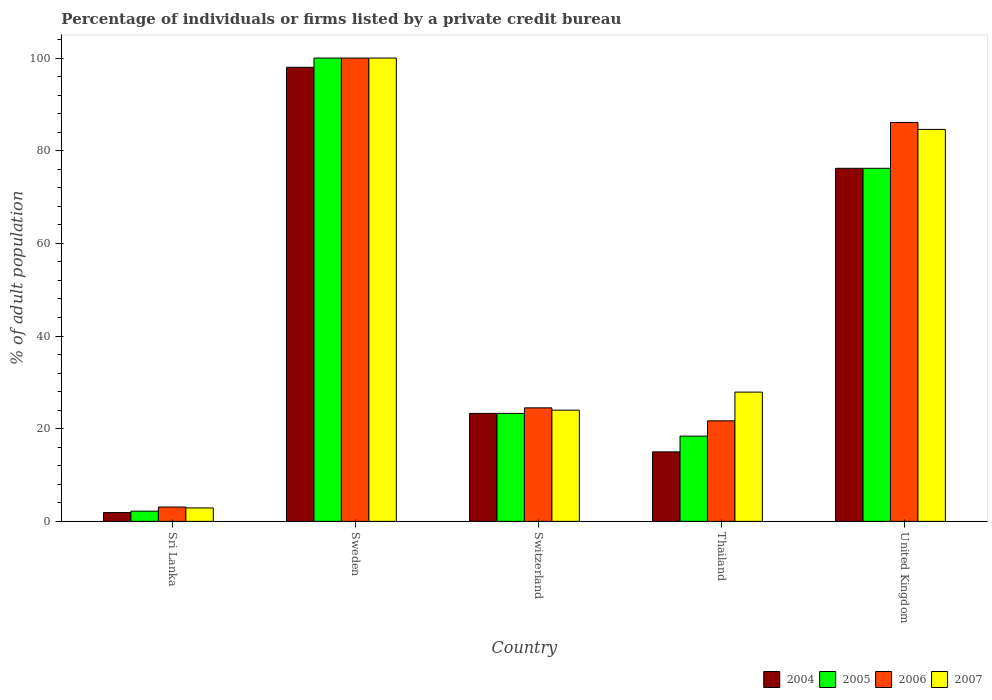How many bars are there on the 2nd tick from the right?
Make the answer very short. 4. What is the label of the 3rd group of bars from the left?
Your answer should be very brief. Switzerland. In how many cases, is the number of bars for a given country not equal to the number of legend labels?
Your answer should be compact. 0. What is the percentage of population listed by a private credit bureau in 2004 in Sri Lanka?
Your response must be concise. 1.9. In which country was the percentage of population listed by a private credit bureau in 2005 maximum?
Your response must be concise. Sweden. In which country was the percentage of population listed by a private credit bureau in 2007 minimum?
Provide a succinct answer. Sri Lanka. What is the total percentage of population listed by a private credit bureau in 2004 in the graph?
Provide a short and direct response. 214.4. What is the difference between the percentage of population listed by a private credit bureau in 2006 in Sri Lanka and that in United Kingdom?
Make the answer very short. -83. What is the difference between the percentage of population listed by a private credit bureau in 2004 in Sri Lanka and the percentage of population listed by a private credit bureau in 2006 in Sweden?
Ensure brevity in your answer.  -98.1. What is the average percentage of population listed by a private credit bureau in 2004 per country?
Your answer should be very brief. 42.88. What is the ratio of the percentage of population listed by a private credit bureau in 2006 in Sri Lanka to that in United Kingdom?
Make the answer very short. 0.04. Is the percentage of population listed by a private credit bureau in 2006 in Sri Lanka less than that in United Kingdom?
Give a very brief answer. Yes. Is the difference between the percentage of population listed by a private credit bureau in 2005 in Thailand and United Kingdom greater than the difference between the percentage of population listed by a private credit bureau in 2007 in Thailand and United Kingdom?
Offer a terse response. No. What is the difference between the highest and the second highest percentage of population listed by a private credit bureau in 2004?
Your answer should be compact. 21.8. What is the difference between the highest and the lowest percentage of population listed by a private credit bureau in 2005?
Give a very brief answer. 97.8. In how many countries, is the percentage of population listed by a private credit bureau in 2006 greater than the average percentage of population listed by a private credit bureau in 2006 taken over all countries?
Your answer should be compact. 2. Is it the case that in every country, the sum of the percentage of population listed by a private credit bureau in 2005 and percentage of population listed by a private credit bureau in 2007 is greater than the sum of percentage of population listed by a private credit bureau in 2004 and percentage of population listed by a private credit bureau in 2006?
Provide a succinct answer. No. What does the 2nd bar from the left in Sweden represents?
Ensure brevity in your answer.  2005. What does the 1st bar from the right in Switzerland represents?
Provide a short and direct response. 2007. How many bars are there?
Offer a very short reply. 20. How many countries are there in the graph?
Offer a terse response. 5. What is the difference between two consecutive major ticks on the Y-axis?
Keep it short and to the point. 20. Does the graph contain any zero values?
Keep it short and to the point. No. Does the graph contain grids?
Your response must be concise. No. Where does the legend appear in the graph?
Offer a terse response. Bottom right. How many legend labels are there?
Your answer should be compact. 4. How are the legend labels stacked?
Provide a short and direct response. Horizontal. What is the title of the graph?
Your answer should be compact. Percentage of individuals or firms listed by a private credit bureau. Does "1975" appear as one of the legend labels in the graph?
Give a very brief answer. No. What is the label or title of the Y-axis?
Your response must be concise. % of adult population. What is the % of adult population of 2006 in Sri Lanka?
Make the answer very short. 3.1. What is the % of adult population in 2007 in Sri Lanka?
Ensure brevity in your answer.  2.9. What is the % of adult population in 2004 in Sweden?
Give a very brief answer. 98. What is the % of adult population of 2006 in Sweden?
Ensure brevity in your answer.  100. What is the % of adult population of 2007 in Sweden?
Give a very brief answer. 100. What is the % of adult population in 2004 in Switzerland?
Keep it short and to the point. 23.3. What is the % of adult population of 2005 in Switzerland?
Offer a very short reply. 23.3. What is the % of adult population of 2007 in Switzerland?
Keep it short and to the point. 24. What is the % of adult population of 2004 in Thailand?
Make the answer very short. 15. What is the % of adult population in 2005 in Thailand?
Make the answer very short. 18.4. What is the % of adult population in 2006 in Thailand?
Provide a short and direct response. 21.7. What is the % of adult population in 2007 in Thailand?
Your answer should be compact. 27.9. What is the % of adult population in 2004 in United Kingdom?
Offer a terse response. 76.2. What is the % of adult population in 2005 in United Kingdom?
Offer a terse response. 76.2. What is the % of adult population of 2006 in United Kingdom?
Provide a succinct answer. 86.1. What is the % of adult population in 2007 in United Kingdom?
Provide a succinct answer. 84.6. Across all countries, what is the maximum % of adult population of 2006?
Offer a very short reply. 100. Across all countries, what is the minimum % of adult population in 2004?
Give a very brief answer. 1.9. What is the total % of adult population of 2004 in the graph?
Give a very brief answer. 214.4. What is the total % of adult population of 2005 in the graph?
Make the answer very short. 220.1. What is the total % of adult population in 2006 in the graph?
Make the answer very short. 235.4. What is the total % of adult population in 2007 in the graph?
Give a very brief answer. 239.4. What is the difference between the % of adult population of 2004 in Sri Lanka and that in Sweden?
Make the answer very short. -96.1. What is the difference between the % of adult population of 2005 in Sri Lanka and that in Sweden?
Offer a terse response. -97.8. What is the difference between the % of adult population in 2006 in Sri Lanka and that in Sweden?
Your answer should be very brief. -96.9. What is the difference between the % of adult population in 2007 in Sri Lanka and that in Sweden?
Give a very brief answer. -97.1. What is the difference between the % of adult population of 2004 in Sri Lanka and that in Switzerland?
Your answer should be very brief. -21.4. What is the difference between the % of adult population of 2005 in Sri Lanka and that in Switzerland?
Offer a terse response. -21.1. What is the difference between the % of adult population in 2006 in Sri Lanka and that in Switzerland?
Keep it short and to the point. -21.4. What is the difference between the % of adult population of 2007 in Sri Lanka and that in Switzerland?
Provide a short and direct response. -21.1. What is the difference between the % of adult population in 2005 in Sri Lanka and that in Thailand?
Your answer should be very brief. -16.2. What is the difference between the % of adult population in 2006 in Sri Lanka and that in Thailand?
Offer a very short reply. -18.6. What is the difference between the % of adult population in 2004 in Sri Lanka and that in United Kingdom?
Make the answer very short. -74.3. What is the difference between the % of adult population of 2005 in Sri Lanka and that in United Kingdom?
Make the answer very short. -74. What is the difference between the % of adult population of 2006 in Sri Lanka and that in United Kingdom?
Make the answer very short. -83. What is the difference between the % of adult population in 2007 in Sri Lanka and that in United Kingdom?
Offer a terse response. -81.7. What is the difference between the % of adult population in 2004 in Sweden and that in Switzerland?
Your response must be concise. 74.7. What is the difference between the % of adult population in 2005 in Sweden and that in Switzerland?
Your response must be concise. 76.7. What is the difference between the % of adult population of 2006 in Sweden and that in Switzerland?
Offer a terse response. 75.5. What is the difference between the % of adult population in 2007 in Sweden and that in Switzerland?
Keep it short and to the point. 76. What is the difference between the % of adult population in 2004 in Sweden and that in Thailand?
Make the answer very short. 83. What is the difference between the % of adult population in 2005 in Sweden and that in Thailand?
Your answer should be compact. 81.6. What is the difference between the % of adult population of 2006 in Sweden and that in Thailand?
Offer a terse response. 78.3. What is the difference between the % of adult population of 2007 in Sweden and that in Thailand?
Provide a short and direct response. 72.1. What is the difference between the % of adult population of 2004 in Sweden and that in United Kingdom?
Make the answer very short. 21.8. What is the difference between the % of adult population of 2005 in Sweden and that in United Kingdom?
Provide a succinct answer. 23.8. What is the difference between the % of adult population of 2006 in Sweden and that in United Kingdom?
Offer a terse response. 13.9. What is the difference between the % of adult population of 2007 in Sweden and that in United Kingdom?
Ensure brevity in your answer.  15.4. What is the difference between the % of adult population of 2004 in Switzerland and that in Thailand?
Offer a very short reply. 8.3. What is the difference between the % of adult population of 2004 in Switzerland and that in United Kingdom?
Your answer should be compact. -52.9. What is the difference between the % of adult population of 2005 in Switzerland and that in United Kingdom?
Ensure brevity in your answer.  -52.9. What is the difference between the % of adult population of 2006 in Switzerland and that in United Kingdom?
Make the answer very short. -61.6. What is the difference between the % of adult population in 2007 in Switzerland and that in United Kingdom?
Make the answer very short. -60.6. What is the difference between the % of adult population of 2004 in Thailand and that in United Kingdom?
Your answer should be very brief. -61.2. What is the difference between the % of adult population in 2005 in Thailand and that in United Kingdom?
Give a very brief answer. -57.8. What is the difference between the % of adult population of 2006 in Thailand and that in United Kingdom?
Keep it short and to the point. -64.4. What is the difference between the % of adult population of 2007 in Thailand and that in United Kingdom?
Your answer should be very brief. -56.7. What is the difference between the % of adult population of 2004 in Sri Lanka and the % of adult population of 2005 in Sweden?
Provide a succinct answer. -98.1. What is the difference between the % of adult population in 2004 in Sri Lanka and the % of adult population in 2006 in Sweden?
Your response must be concise. -98.1. What is the difference between the % of adult population in 2004 in Sri Lanka and the % of adult population in 2007 in Sweden?
Provide a succinct answer. -98.1. What is the difference between the % of adult population in 2005 in Sri Lanka and the % of adult population in 2006 in Sweden?
Your answer should be compact. -97.8. What is the difference between the % of adult population of 2005 in Sri Lanka and the % of adult population of 2007 in Sweden?
Provide a short and direct response. -97.8. What is the difference between the % of adult population in 2006 in Sri Lanka and the % of adult population in 2007 in Sweden?
Offer a very short reply. -96.9. What is the difference between the % of adult population in 2004 in Sri Lanka and the % of adult population in 2005 in Switzerland?
Offer a very short reply. -21.4. What is the difference between the % of adult population in 2004 in Sri Lanka and the % of adult population in 2006 in Switzerland?
Keep it short and to the point. -22.6. What is the difference between the % of adult population in 2004 in Sri Lanka and the % of adult population in 2007 in Switzerland?
Your answer should be very brief. -22.1. What is the difference between the % of adult population of 2005 in Sri Lanka and the % of adult population of 2006 in Switzerland?
Make the answer very short. -22.3. What is the difference between the % of adult population of 2005 in Sri Lanka and the % of adult population of 2007 in Switzerland?
Make the answer very short. -21.8. What is the difference between the % of adult population in 2006 in Sri Lanka and the % of adult population in 2007 in Switzerland?
Offer a terse response. -20.9. What is the difference between the % of adult population of 2004 in Sri Lanka and the % of adult population of 2005 in Thailand?
Give a very brief answer. -16.5. What is the difference between the % of adult population in 2004 in Sri Lanka and the % of adult population in 2006 in Thailand?
Offer a terse response. -19.8. What is the difference between the % of adult population in 2005 in Sri Lanka and the % of adult population in 2006 in Thailand?
Your answer should be very brief. -19.5. What is the difference between the % of adult population in 2005 in Sri Lanka and the % of adult population in 2007 in Thailand?
Your answer should be very brief. -25.7. What is the difference between the % of adult population of 2006 in Sri Lanka and the % of adult population of 2007 in Thailand?
Offer a terse response. -24.8. What is the difference between the % of adult population in 2004 in Sri Lanka and the % of adult population in 2005 in United Kingdom?
Offer a very short reply. -74.3. What is the difference between the % of adult population in 2004 in Sri Lanka and the % of adult population in 2006 in United Kingdom?
Make the answer very short. -84.2. What is the difference between the % of adult population of 2004 in Sri Lanka and the % of adult population of 2007 in United Kingdom?
Offer a very short reply. -82.7. What is the difference between the % of adult population of 2005 in Sri Lanka and the % of adult population of 2006 in United Kingdom?
Make the answer very short. -83.9. What is the difference between the % of adult population of 2005 in Sri Lanka and the % of adult population of 2007 in United Kingdom?
Give a very brief answer. -82.4. What is the difference between the % of adult population of 2006 in Sri Lanka and the % of adult population of 2007 in United Kingdom?
Make the answer very short. -81.5. What is the difference between the % of adult population in 2004 in Sweden and the % of adult population in 2005 in Switzerland?
Offer a terse response. 74.7. What is the difference between the % of adult population in 2004 in Sweden and the % of adult population in 2006 in Switzerland?
Provide a succinct answer. 73.5. What is the difference between the % of adult population of 2004 in Sweden and the % of adult population of 2007 in Switzerland?
Keep it short and to the point. 74. What is the difference between the % of adult population of 2005 in Sweden and the % of adult population of 2006 in Switzerland?
Your response must be concise. 75.5. What is the difference between the % of adult population of 2004 in Sweden and the % of adult population of 2005 in Thailand?
Provide a succinct answer. 79.6. What is the difference between the % of adult population of 2004 in Sweden and the % of adult population of 2006 in Thailand?
Ensure brevity in your answer.  76.3. What is the difference between the % of adult population of 2004 in Sweden and the % of adult population of 2007 in Thailand?
Keep it short and to the point. 70.1. What is the difference between the % of adult population of 2005 in Sweden and the % of adult population of 2006 in Thailand?
Offer a very short reply. 78.3. What is the difference between the % of adult population in 2005 in Sweden and the % of adult population in 2007 in Thailand?
Make the answer very short. 72.1. What is the difference between the % of adult population in 2006 in Sweden and the % of adult population in 2007 in Thailand?
Ensure brevity in your answer.  72.1. What is the difference between the % of adult population in 2004 in Sweden and the % of adult population in 2005 in United Kingdom?
Keep it short and to the point. 21.8. What is the difference between the % of adult population in 2004 in Sweden and the % of adult population in 2007 in United Kingdom?
Ensure brevity in your answer.  13.4. What is the difference between the % of adult population in 2006 in Sweden and the % of adult population in 2007 in United Kingdom?
Provide a short and direct response. 15.4. What is the difference between the % of adult population in 2004 in Switzerland and the % of adult population in 2006 in Thailand?
Your answer should be very brief. 1.6. What is the difference between the % of adult population of 2004 in Switzerland and the % of adult population of 2007 in Thailand?
Offer a terse response. -4.6. What is the difference between the % of adult population in 2005 in Switzerland and the % of adult population in 2006 in Thailand?
Your response must be concise. 1.6. What is the difference between the % of adult population of 2006 in Switzerland and the % of adult population of 2007 in Thailand?
Make the answer very short. -3.4. What is the difference between the % of adult population of 2004 in Switzerland and the % of adult population of 2005 in United Kingdom?
Provide a succinct answer. -52.9. What is the difference between the % of adult population of 2004 in Switzerland and the % of adult population of 2006 in United Kingdom?
Make the answer very short. -62.8. What is the difference between the % of adult population of 2004 in Switzerland and the % of adult population of 2007 in United Kingdom?
Provide a short and direct response. -61.3. What is the difference between the % of adult population in 2005 in Switzerland and the % of adult population in 2006 in United Kingdom?
Ensure brevity in your answer.  -62.8. What is the difference between the % of adult population of 2005 in Switzerland and the % of adult population of 2007 in United Kingdom?
Offer a very short reply. -61.3. What is the difference between the % of adult population in 2006 in Switzerland and the % of adult population in 2007 in United Kingdom?
Make the answer very short. -60.1. What is the difference between the % of adult population of 2004 in Thailand and the % of adult population of 2005 in United Kingdom?
Ensure brevity in your answer.  -61.2. What is the difference between the % of adult population of 2004 in Thailand and the % of adult population of 2006 in United Kingdom?
Offer a very short reply. -71.1. What is the difference between the % of adult population of 2004 in Thailand and the % of adult population of 2007 in United Kingdom?
Your response must be concise. -69.6. What is the difference between the % of adult population of 2005 in Thailand and the % of adult population of 2006 in United Kingdom?
Keep it short and to the point. -67.7. What is the difference between the % of adult population of 2005 in Thailand and the % of adult population of 2007 in United Kingdom?
Offer a terse response. -66.2. What is the difference between the % of adult population in 2006 in Thailand and the % of adult population in 2007 in United Kingdom?
Ensure brevity in your answer.  -62.9. What is the average % of adult population of 2004 per country?
Provide a succinct answer. 42.88. What is the average % of adult population in 2005 per country?
Your answer should be very brief. 44.02. What is the average % of adult population in 2006 per country?
Offer a very short reply. 47.08. What is the average % of adult population in 2007 per country?
Make the answer very short. 47.88. What is the difference between the % of adult population of 2004 and % of adult population of 2005 in Sri Lanka?
Make the answer very short. -0.3. What is the difference between the % of adult population in 2004 and % of adult population in 2007 in Sri Lanka?
Keep it short and to the point. -1. What is the difference between the % of adult population in 2004 and % of adult population in 2007 in Sweden?
Your response must be concise. -2. What is the difference between the % of adult population of 2005 and % of adult population of 2007 in Sweden?
Offer a very short reply. 0. What is the difference between the % of adult population of 2006 and % of adult population of 2007 in Sweden?
Ensure brevity in your answer.  0. What is the difference between the % of adult population in 2004 and % of adult population in 2006 in Switzerland?
Offer a very short reply. -1.2. What is the difference between the % of adult population in 2004 and % of adult population in 2007 in Switzerland?
Provide a short and direct response. -0.7. What is the difference between the % of adult population in 2005 and % of adult population in 2007 in Switzerland?
Your response must be concise. -0.7. What is the difference between the % of adult population in 2006 and % of adult population in 2007 in Switzerland?
Offer a very short reply. 0.5. What is the difference between the % of adult population of 2005 and % of adult population of 2006 in Thailand?
Ensure brevity in your answer.  -3.3. What is the difference between the % of adult population in 2005 and % of adult population in 2007 in Thailand?
Provide a succinct answer. -9.5. What is the difference between the % of adult population of 2006 and % of adult population of 2007 in Thailand?
Ensure brevity in your answer.  -6.2. What is the difference between the % of adult population in 2005 and % of adult population in 2006 in United Kingdom?
Give a very brief answer. -9.9. What is the difference between the % of adult population in 2005 and % of adult population in 2007 in United Kingdom?
Keep it short and to the point. -8.4. What is the ratio of the % of adult population of 2004 in Sri Lanka to that in Sweden?
Your answer should be compact. 0.02. What is the ratio of the % of adult population in 2005 in Sri Lanka to that in Sweden?
Make the answer very short. 0.02. What is the ratio of the % of adult population of 2006 in Sri Lanka to that in Sweden?
Your answer should be very brief. 0.03. What is the ratio of the % of adult population of 2007 in Sri Lanka to that in Sweden?
Ensure brevity in your answer.  0.03. What is the ratio of the % of adult population in 2004 in Sri Lanka to that in Switzerland?
Provide a succinct answer. 0.08. What is the ratio of the % of adult population in 2005 in Sri Lanka to that in Switzerland?
Your answer should be compact. 0.09. What is the ratio of the % of adult population in 2006 in Sri Lanka to that in Switzerland?
Provide a short and direct response. 0.13. What is the ratio of the % of adult population of 2007 in Sri Lanka to that in Switzerland?
Your answer should be compact. 0.12. What is the ratio of the % of adult population in 2004 in Sri Lanka to that in Thailand?
Give a very brief answer. 0.13. What is the ratio of the % of adult population of 2005 in Sri Lanka to that in Thailand?
Your answer should be compact. 0.12. What is the ratio of the % of adult population of 2006 in Sri Lanka to that in Thailand?
Ensure brevity in your answer.  0.14. What is the ratio of the % of adult population of 2007 in Sri Lanka to that in Thailand?
Your response must be concise. 0.1. What is the ratio of the % of adult population of 2004 in Sri Lanka to that in United Kingdom?
Make the answer very short. 0.02. What is the ratio of the % of adult population in 2005 in Sri Lanka to that in United Kingdom?
Keep it short and to the point. 0.03. What is the ratio of the % of adult population in 2006 in Sri Lanka to that in United Kingdom?
Your answer should be very brief. 0.04. What is the ratio of the % of adult population in 2007 in Sri Lanka to that in United Kingdom?
Provide a succinct answer. 0.03. What is the ratio of the % of adult population of 2004 in Sweden to that in Switzerland?
Your answer should be very brief. 4.21. What is the ratio of the % of adult population of 2005 in Sweden to that in Switzerland?
Provide a short and direct response. 4.29. What is the ratio of the % of adult population of 2006 in Sweden to that in Switzerland?
Give a very brief answer. 4.08. What is the ratio of the % of adult population in 2007 in Sweden to that in Switzerland?
Your answer should be compact. 4.17. What is the ratio of the % of adult population of 2004 in Sweden to that in Thailand?
Offer a terse response. 6.53. What is the ratio of the % of adult population of 2005 in Sweden to that in Thailand?
Your response must be concise. 5.43. What is the ratio of the % of adult population in 2006 in Sweden to that in Thailand?
Ensure brevity in your answer.  4.61. What is the ratio of the % of adult population in 2007 in Sweden to that in Thailand?
Ensure brevity in your answer.  3.58. What is the ratio of the % of adult population in 2004 in Sweden to that in United Kingdom?
Your answer should be very brief. 1.29. What is the ratio of the % of adult population in 2005 in Sweden to that in United Kingdom?
Offer a terse response. 1.31. What is the ratio of the % of adult population in 2006 in Sweden to that in United Kingdom?
Your response must be concise. 1.16. What is the ratio of the % of adult population in 2007 in Sweden to that in United Kingdom?
Provide a succinct answer. 1.18. What is the ratio of the % of adult population in 2004 in Switzerland to that in Thailand?
Provide a succinct answer. 1.55. What is the ratio of the % of adult population of 2005 in Switzerland to that in Thailand?
Keep it short and to the point. 1.27. What is the ratio of the % of adult population of 2006 in Switzerland to that in Thailand?
Offer a terse response. 1.13. What is the ratio of the % of adult population of 2007 in Switzerland to that in Thailand?
Provide a succinct answer. 0.86. What is the ratio of the % of adult population of 2004 in Switzerland to that in United Kingdom?
Your answer should be very brief. 0.31. What is the ratio of the % of adult population of 2005 in Switzerland to that in United Kingdom?
Offer a very short reply. 0.31. What is the ratio of the % of adult population of 2006 in Switzerland to that in United Kingdom?
Offer a very short reply. 0.28. What is the ratio of the % of adult population in 2007 in Switzerland to that in United Kingdom?
Offer a terse response. 0.28. What is the ratio of the % of adult population of 2004 in Thailand to that in United Kingdom?
Make the answer very short. 0.2. What is the ratio of the % of adult population of 2005 in Thailand to that in United Kingdom?
Your answer should be compact. 0.24. What is the ratio of the % of adult population of 2006 in Thailand to that in United Kingdom?
Keep it short and to the point. 0.25. What is the ratio of the % of adult population of 2007 in Thailand to that in United Kingdom?
Keep it short and to the point. 0.33. What is the difference between the highest and the second highest % of adult population of 2004?
Make the answer very short. 21.8. What is the difference between the highest and the second highest % of adult population in 2005?
Ensure brevity in your answer.  23.8. What is the difference between the highest and the second highest % of adult population in 2006?
Offer a terse response. 13.9. What is the difference between the highest and the lowest % of adult population in 2004?
Give a very brief answer. 96.1. What is the difference between the highest and the lowest % of adult population of 2005?
Your answer should be compact. 97.8. What is the difference between the highest and the lowest % of adult population of 2006?
Give a very brief answer. 96.9. What is the difference between the highest and the lowest % of adult population of 2007?
Make the answer very short. 97.1. 